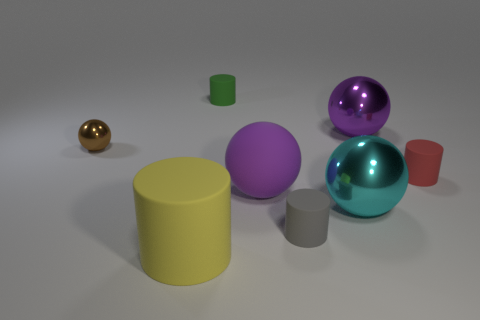Can you tell me more about the smallest sphere in the scene? Certainly! The smallest sphere in the image, which has a gold color, suggests a metallic finish. It could be indicative of a material like polished brass or gold-painted metal. 